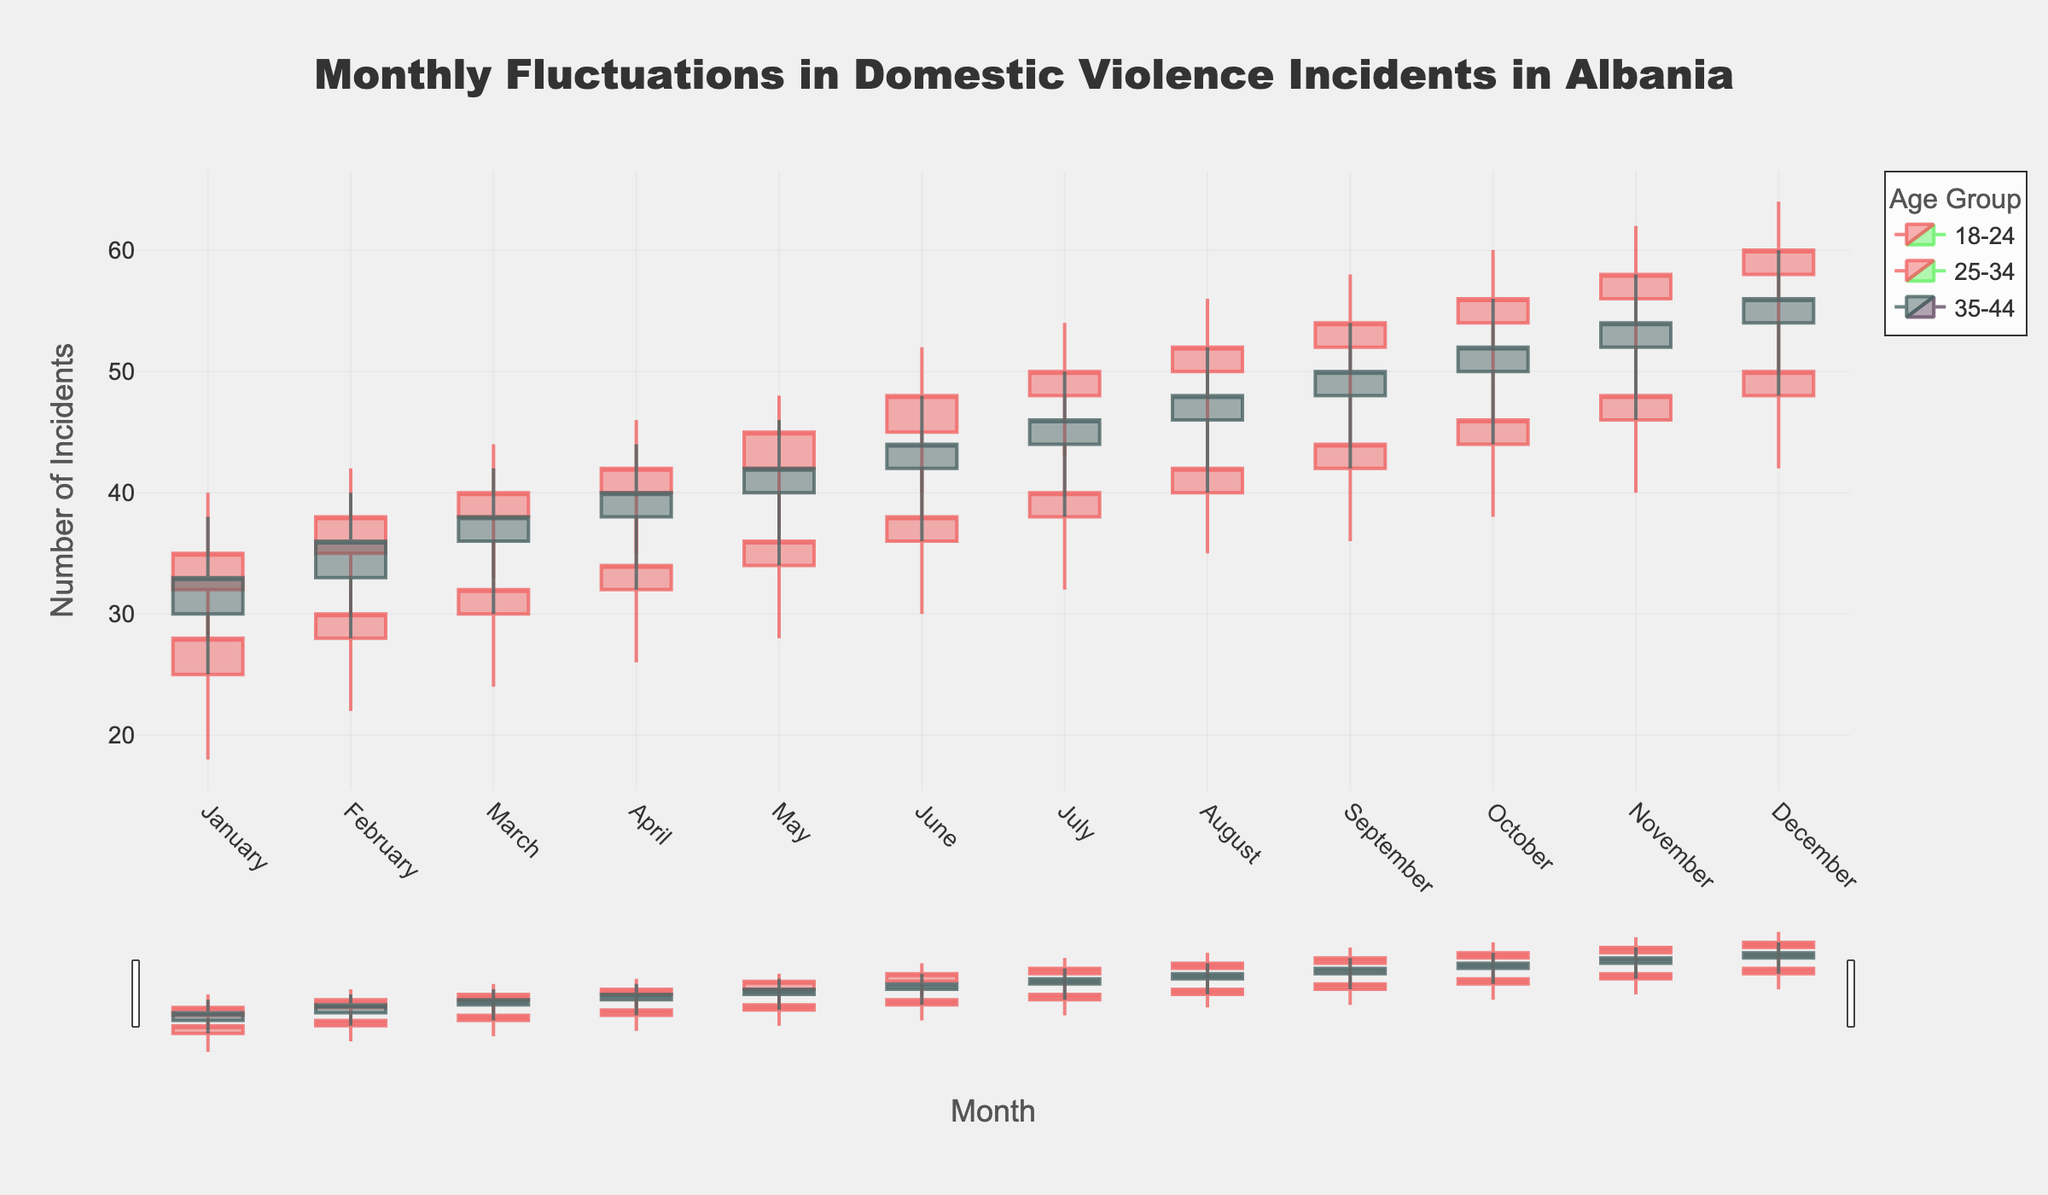What's the title of the chart? The title is prominently displayed at the top of the figure.
Answer: Monthly Fluctuations in Domestic Violence Incidents in Albania How many age groups are represented in the plot? Each color or legend entry corresponds to a different age group. By examining the legend, we see three age groups are represented.
Answer: 3 Which month had the highest peak in incidents for the 25-34 age group? By looking at the high points of the candlesticks for the 25-34 age group, the highest peak is in December.
Answer: December What is the difference between the highest and lowest number of incidents in January for the 18-24 age group? The high point is 30 and the low point is 18. The difference is calculated by subtracting the low from the high. So, 30 - 18 = 12.
Answer: 12 For which month did the 35-44 age group show the highest increase between the opening and closing number of incidents? To find this, compare the differences (close - open) for each month in the 35-44 age group. The largest increase is from January (33 - 30 = 3).
Answer: January Between which two months did the number of incidents for the 18-24 age group go from the highest to the lowest? Looking at the close values of 18-24 age group across the months, the highest close is in December (50) and the lowest close is in January (28).
Answer: December to January Which month saw the least fluctuation in the number of incidents reported for the 25-34 age group? The least fluctuation can be identified by the smallest range (high - low) for the 25-34 age group. This happens in February where high is 42 and low is 30 (42-30=12).
Answer: February What was the closing value for the 35-44 age group in November? Locate the candlestick for November under the 35-44 age group and check the closing value which is at the end of the candlestick. The closing value is 54.
Answer: 54 How did the 18-24 age group's number of incidents change from November to December? To compare, look at the closing values for November (48) and December (50). The change is calculated as 50 - 48 = 2, indicating an increase of 2 incidents.
Answer: Increased by 2 